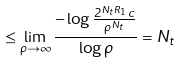<formula> <loc_0><loc_0><loc_500><loc_500>\leq \lim _ { \rho \rightarrow \infty } \frac { - \log \frac { 2 ^ { N _ { t } R _ { 1 } } c } { \rho ^ { N _ { t } } } } { \log \rho } = N _ { t }</formula> 